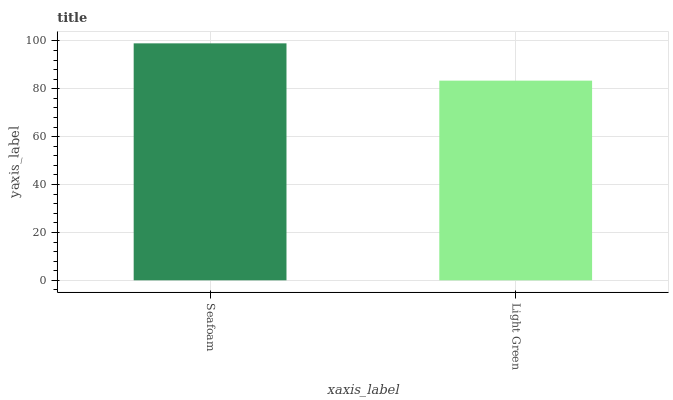Is Light Green the maximum?
Answer yes or no. No. Is Seafoam greater than Light Green?
Answer yes or no. Yes. Is Light Green less than Seafoam?
Answer yes or no. Yes. Is Light Green greater than Seafoam?
Answer yes or no. No. Is Seafoam less than Light Green?
Answer yes or no. No. Is Seafoam the high median?
Answer yes or no. Yes. Is Light Green the low median?
Answer yes or no. Yes. Is Light Green the high median?
Answer yes or no. No. Is Seafoam the low median?
Answer yes or no. No. 